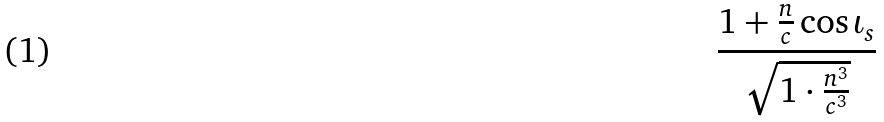<formula> <loc_0><loc_0><loc_500><loc_500>\frac { 1 + \frac { n } { c } \cos \iota _ { s } } { \sqrt { 1 \cdot \frac { n ^ { 3 } } { c ^ { 3 } } } }</formula> 